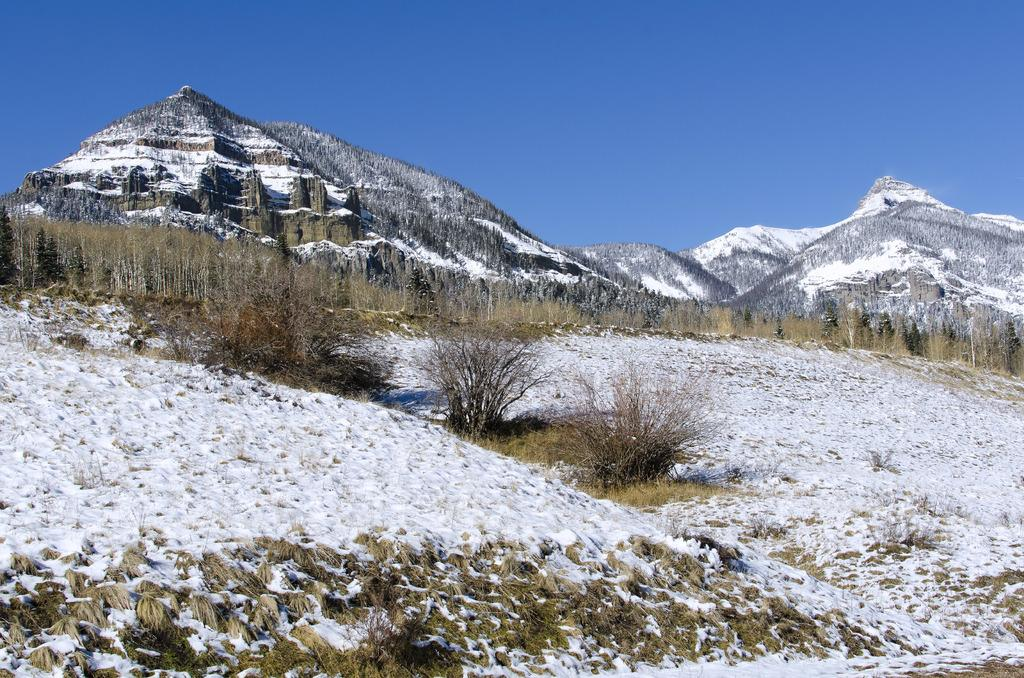What is the condition of the ground in the image? The ground is covered with snow. What can be seen in the background of the image? There are mountains in the background of the image. How are the mountains affected by the snow? The mountains are covered with snow. How much sugar is present in the snow in the image? There is no sugar present in the snow in the image; it is just snow. 